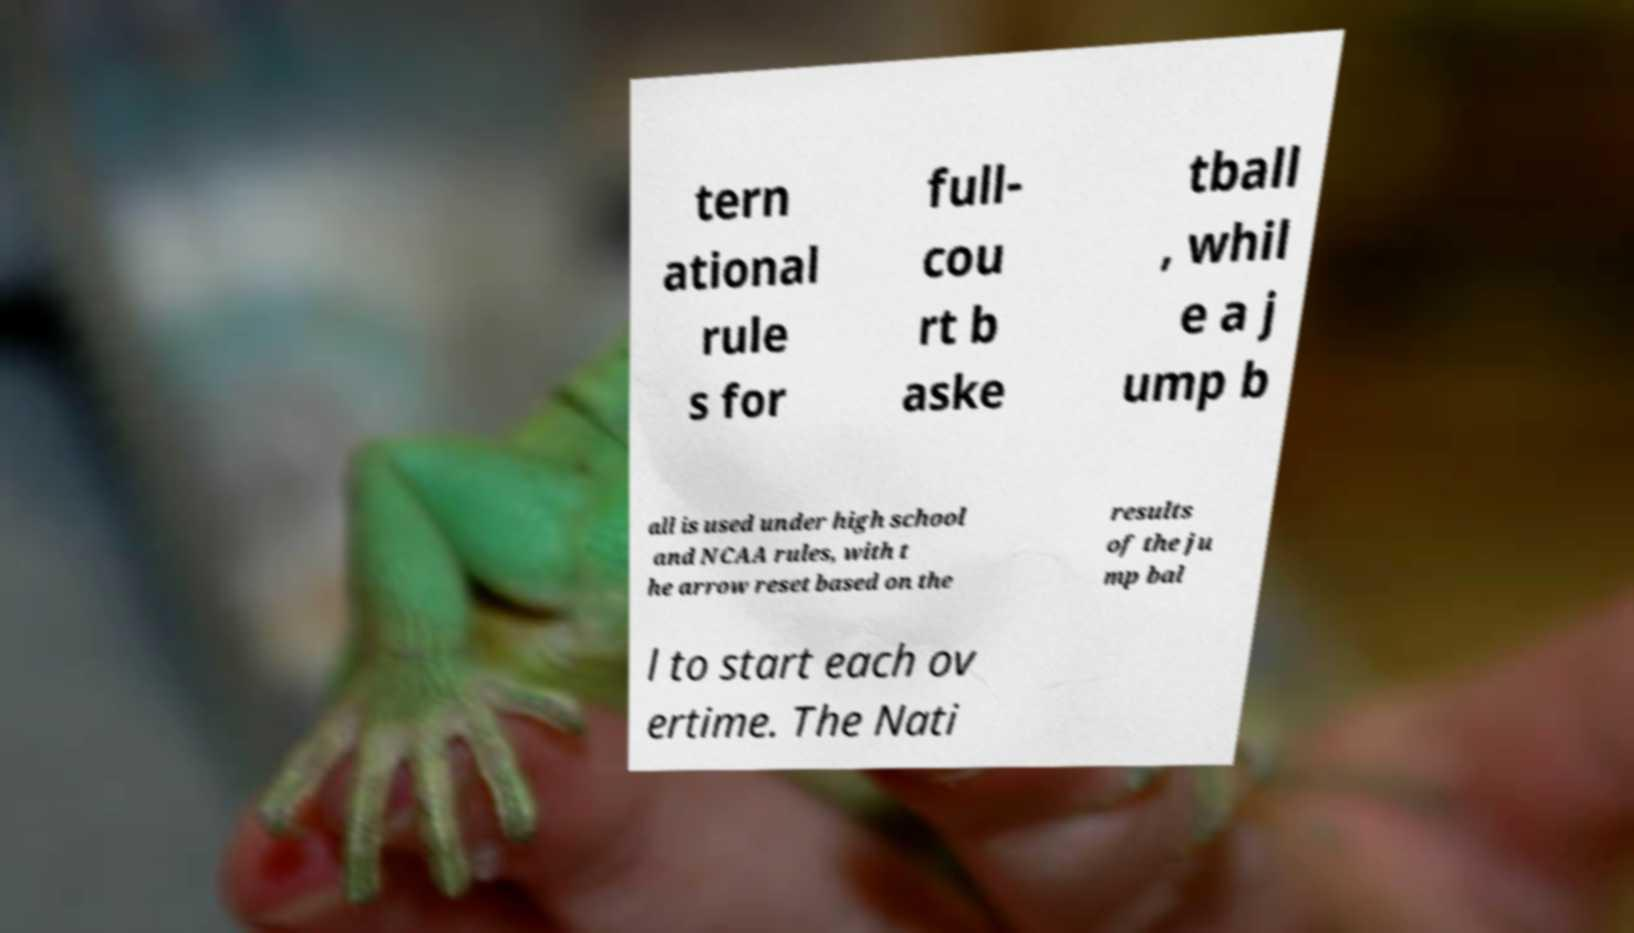Could you assist in decoding the text presented in this image and type it out clearly? tern ational rule s for full- cou rt b aske tball , whil e a j ump b all is used under high school and NCAA rules, with t he arrow reset based on the results of the ju mp bal l to start each ov ertime. The Nati 